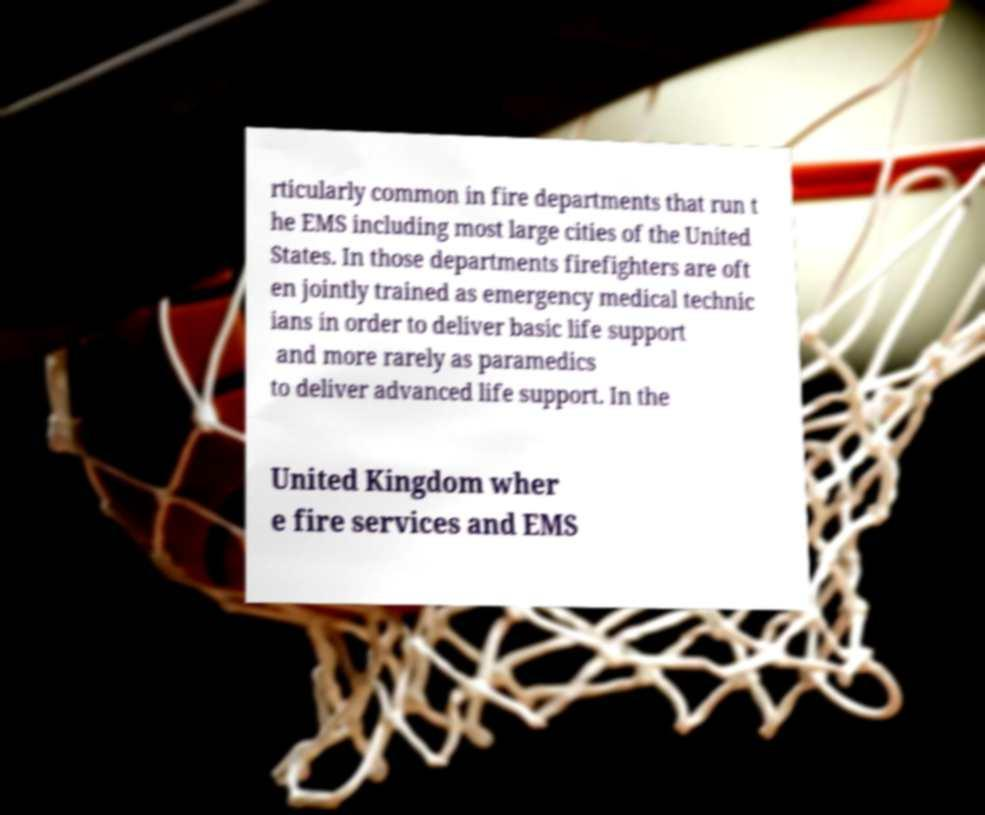Could you assist in decoding the text presented in this image and type it out clearly? rticularly common in fire departments that run t he EMS including most large cities of the United States. In those departments firefighters are oft en jointly trained as emergency medical technic ians in order to deliver basic life support and more rarely as paramedics to deliver advanced life support. In the United Kingdom wher e fire services and EMS 